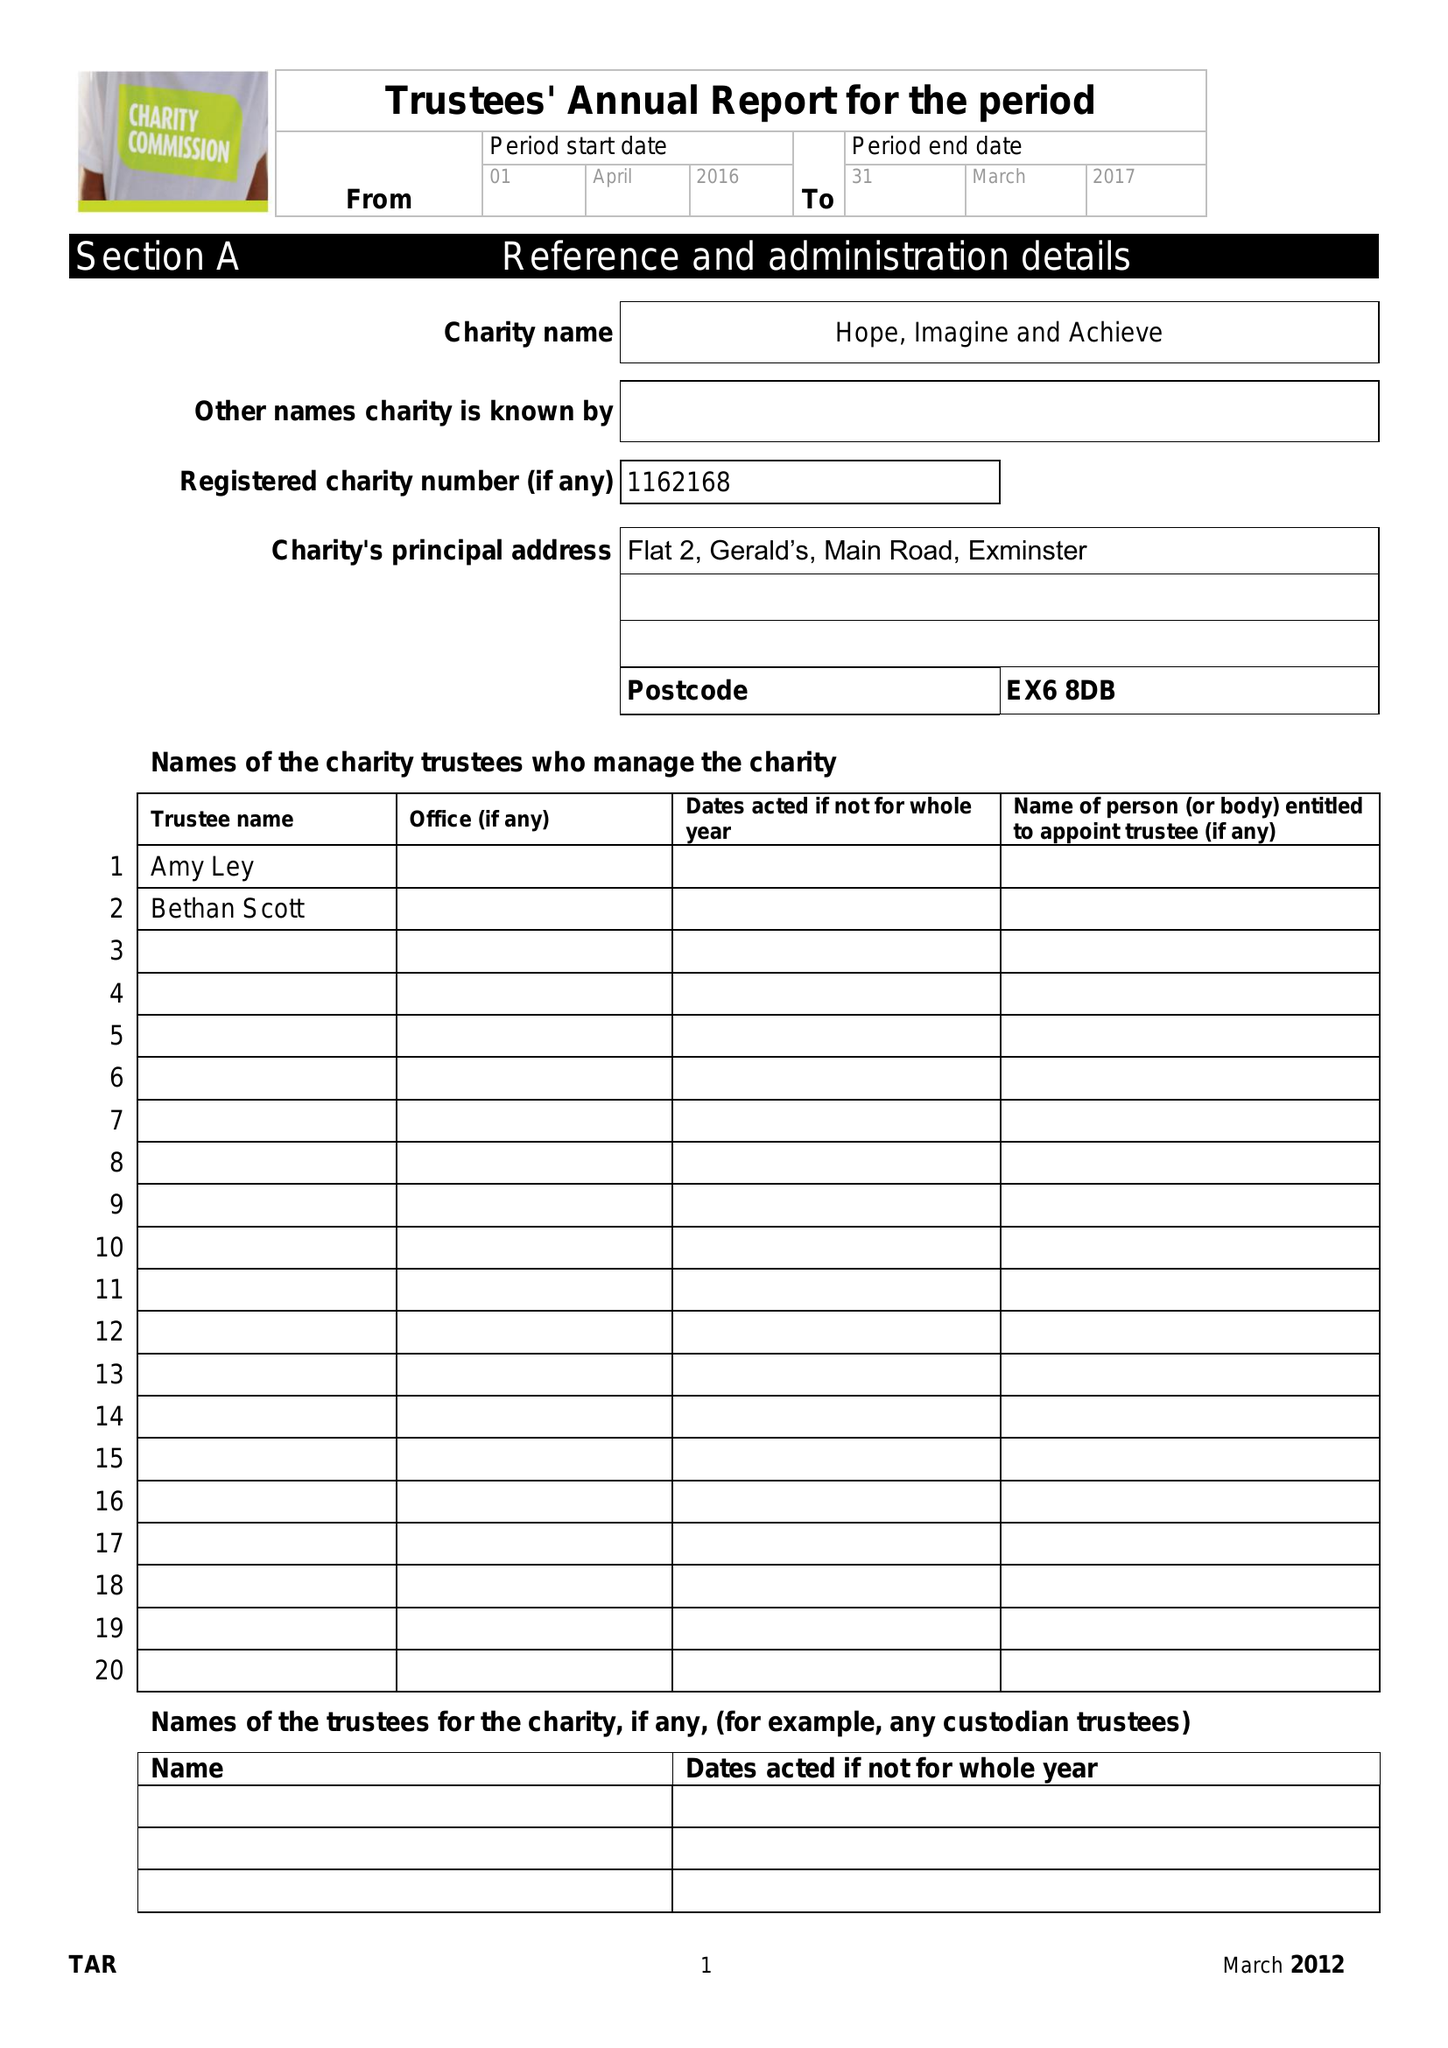What is the value for the address__street_line?
Answer the question using a single word or phrase. None 